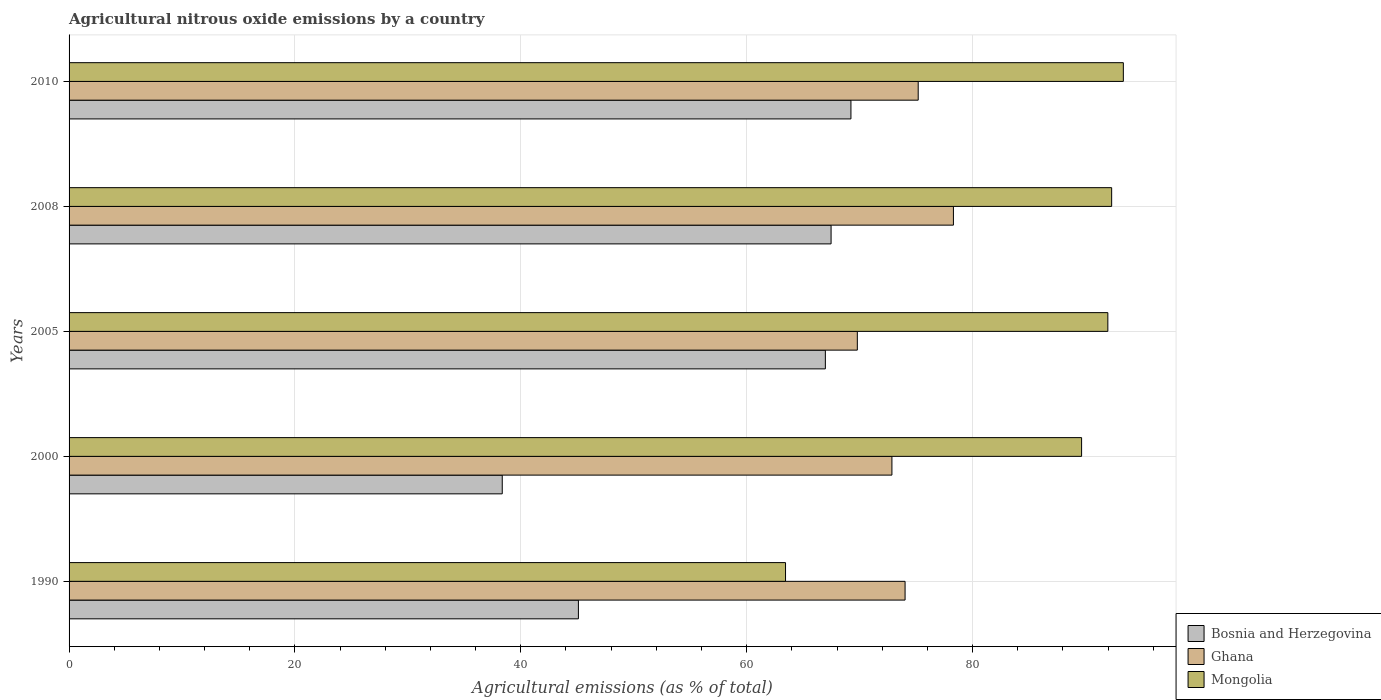How many different coloured bars are there?
Provide a succinct answer. 3. How many bars are there on the 3rd tick from the bottom?
Make the answer very short. 3. What is the amount of agricultural nitrous oxide emitted in Mongolia in 2005?
Provide a succinct answer. 91.98. Across all years, what is the maximum amount of agricultural nitrous oxide emitted in Ghana?
Offer a very short reply. 78.31. Across all years, what is the minimum amount of agricultural nitrous oxide emitted in Mongolia?
Your response must be concise. 63.44. In which year was the amount of agricultural nitrous oxide emitted in Ghana minimum?
Make the answer very short. 2005. What is the total amount of agricultural nitrous oxide emitted in Bosnia and Herzegovina in the graph?
Your answer should be very brief. 287.13. What is the difference between the amount of agricultural nitrous oxide emitted in Ghana in 2008 and that in 2010?
Your answer should be very brief. 3.12. What is the difference between the amount of agricultural nitrous oxide emitted in Mongolia in 2010 and the amount of agricultural nitrous oxide emitted in Bosnia and Herzegovina in 2000?
Give a very brief answer. 55. What is the average amount of agricultural nitrous oxide emitted in Bosnia and Herzegovina per year?
Offer a terse response. 57.43. In the year 1990, what is the difference between the amount of agricultural nitrous oxide emitted in Ghana and amount of agricultural nitrous oxide emitted in Bosnia and Herzegovina?
Offer a terse response. 28.93. In how many years, is the amount of agricultural nitrous oxide emitted in Mongolia greater than 92 %?
Offer a terse response. 2. What is the ratio of the amount of agricultural nitrous oxide emitted in Ghana in 2005 to that in 2008?
Provide a succinct answer. 0.89. Is the amount of agricultural nitrous oxide emitted in Bosnia and Herzegovina in 2000 less than that in 2008?
Provide a succinct answer. Yes. What is the difference between the highest and the second highest amount of agricultural nitrous oxide emitted in Ghana?
Give a very brief answer. 3.12. What is the difference between the highest and the lowest amount of agricultural nitrous oxide emitted in Mongolia?
Provide a succinct answer. 29.91. In how many years, is the amount of agricultural nitrous oxide emitted in Ghana greater than the average amount of agricultural nitrous oxide emitted in Ghana taken over all years?
Give a very brief answer. 2. Is the sum of the amount of agricultural nitrous oxide emitted in Bosnia and Herzegovina in 2005 and 2008 greater than the maximum amount of agricultural nitrous oxide emitted in Ghana across all years?
Your answer should be compact. Yes. What does the 3rd bar from the top in 2005 represents?
Provide a short and direct response. Bosnia and Herzegovina. Are all the bars in the graph horizontal?
Provide a short and direct response. Yes. Are the values on the major ticks of X-axis written in scientific E-notation?
Keep it short and to the point. No. Does the graph contain any zero values?
Make the answer very short. No. Does the graph contain grids?
Offer a terse response. Yes. How are the legend labels stacked?
Make the answer very short. Vertical. What is the title of the graph?
Keep it short and to the point. Agricultural nitrous oxide emissions by a country. Does "Timor-Leste" appear as one of the legend labels in the graph?
Offer a terse response. No. What is the label or title of the X-axis?
Your answer should be very brief. Agricultural emissions (as % of total). What is the Agricultural emissions (as % of total) of Bosnia and Herzegovina in 1990?
Offer a terse response. 45.1. What is the Agricultural emissions (as % of total) in Ghana in 1990?
Your answer should be very brief. 74.03. What is the Agricultural emissions (as % of total) of Mongolia in 1990?
Make the answer very short. 63.44. What is the Agricultural emissions (as % of total) of Bosnia and Herzegovina in 2000?
Give a very brief answer. 38.36. What is the Agricultural emissions (as % of total) in Ghana in 2000?
Your response must be concise. 72.86. What is the Agricultural emissions (as % of total) of Mongolia in 2000?
Your response must be concise. 89.66. What is the Agricultural emissions (as % of total) of Bosnia and Herzegovina in 2005?
Provide a succinct answer. 66.97. What is the Agricultural emissions (as % of total) of Ghana in 2005?
Your answer should be compact. 69.8. What is the Agricultural emissions (as % of total) of Mongolia in 2005?
Ensure brevity in your answer.  91.98. What is the Agricultural emissions (as % of total) of Bosnia and Herzegovina in 2008?
Make the answer very short. 67.47. What is the Agricultural emissions (as % of total) in Ghana in 2008?
Your answer should be very brief. 78.31. What is the Agricultural emissions (as % of total) of Mongolia in 2008?
Give a very brief answer. 92.32. What is the Agricultural emissions (as % of total) of Bosnia and Herzegovina in 2010?
Offer a terse response. 69.23. What is the Agricultural emissions (as % of total) in Ghana in 2010?
Your response must be concise. 75.19. What is the Agricultural emissions (as % of total) of Mongolia in 2010?
Keep it short and to the point. 93.35. Across all years, what is the maximum Agricultural emissions (as % of total) of Bosnia and Herzegovina?
Your response must be concise. 69.23. Across all years, what is the maximum Agricultural emissions (as % of total) in Ghana?
Provide a short and direct response. 78.31. Across all years, what is the maximum Agricultural emissions (as % of total) of Mongolia?
Your response must be concise. 93.35. Across all years, what is the minimum Agricultural emissions (as % of total) in Bosnia and Herzegovina?
Ensure brevity in your answer.  38.36. Across all years, what is the minimum Agricultural emissions (as % of total) in Ghana?
Keep it short and to the point. 69.8. Across all years, what is the minimum Agricultural emissions (as % of total) in Mongolia?
Your answer should be compact. 63.44. What is the total Agricultural emissions (as % of total) of Bosnia and Herzegovina in the graph?
Provide a short and direct response. 287.13. What is the total Agricultural emissions (as % of total) in Ghana in the graph?
Your answer should be compact. 370.18. What is the total Agricultural emissions (as % of total) in Mongolia in the graph?
Ensure brevity in your answer.  430.75. What is the difference between the Agricultural emissions (as % of total) of Bosnia and Herzegovina in 1990 and that in 2000?
Offer a terse response. 6.74. What is the difference between the Agricultural emissions (as % of total) in Ghana in 1990 and that in 2000?
Keep it short and to the point. 1.17. What is the difference between the Agricultural emissions (as % of total) of Mongolia in 1990 and that in 2000?
Keep it short and to the point. -26.22. What is the difference between the Agricultural emissions (as % of total) of Bosnia and Herzegovina in 1990 and that in 2005?
Ensure brevity in your answer.  -21.87. What is the difference between the Agricultural emissions (as % of total) in Ghana in 1990 and that in 2005?
Give a very brief answer. 4.23. What is the difference between the Agricultural emissions (as % of total) in Mongolia in 1990 and that in 2005?
Make the answer very short. -28.54. What is the difference between the Agricultural emissions (as % of total) of Bosnia and Herzegovina in 1990 and that in 2008?
Offer a very short reply. -22.37. What is the difference between the Agricultural emissions (as % of total) in Ghana in 1990 and that in 2008?
Your response must be concise. -4.28. What is the difference between the Agricultural emissions (as % of total) of Mongolia in 1990 and that in 2008?
Keep it short and to the point. -28.88. What is the difference between the Agricultural emissions (as % of total) in Bosnia and Herzegovina in 1990 and that in 2010?
Your answer should be compact. -24.13. What is the difference between the Agricultural emissions (as % of total) of Ghana in 1990 and that in 2010?
Keep it short and to the point. -1.16. What is the difference between the Agricultural emissions (as % of total) of Mongolia in 1990 and that in 2010?
Your response must be concise. -29.91. What is the difference between the Agricultural emissions (as % of total) in Bosnia and Herzegovina in 2000 and that in 2005?
Keep it short and to the point. -28.61. What is the difference between the Agricultural emissions (as % of total) in Ghana in 2000 and that in 2005?
Ensure brevity in your answer.  3.06. What is the difference between the Agricultural emissions (as % of total) of Mongolia in 2000 and that in 2005?
Keep it short and to the point. -2.32. What is the difference between the Agricultural emissions (as % of total) of Bosnia and Herzegovina in 2000 and that in 2008?
Your response must be concise. -29.12. What is the difference between the Agricultural emissions (as % of total) of Ghana in 2000 and that in 2008?
Ensure brevity in your answer.  -5.45. What is the difference between the Agricultural emissions (as % of total) in Mongolia in 2000 and that in 2008?
Offer a terse response. -2.66. What is the difference between the Agricultural emissions (as % of total) of Bosnia and Herzegovina in 2000 and that in 2010?
Offer a terse response. -30.88. What is the difference between the Agricultural emissions (as % of total) in Ghana in 2000 and that in 2010?
Offer a very short reply. -2.33. What is the difference between the Agricultural emissions (as % of total) in Mongolia in 2000 and that in 2010?
Your response must be concise. -3.7. What is the difference between the Agricultural emissions (as % of total) of Bosnia and Herzegovina in 2005 and that in 2008?
Provide a succinct answer. -0.51. What is the difference between the Agricultural emissions (as % of total) in Ghana in 2005 and that in 2008?
Give a very brief answer. -8.51. What is the difference between the Agricultural emissions (as % of total) of Mongolia in 2005 and that in 2008?
Provide a short and direct response. -0.34. What is the difference between the Agricultural emissions (as % of total) of Bosnia and Herzegovina in 2005 and that in 2010?
Keep it short and to the point. -2.27. What is the difference between the Agricultural emissions (as % of total) in Ghana in 2005 and that in 2010?
Ensure brevity in your answer.  -5.39. What is the difference between the Agricultural emissions (as % of total) in Mongolia in 2005 and that in 2010?
Offer a terse response. -1.37. What is the difference between the Agricultural emissions (as % of total) of Bosnia and Herzegovina in 2008 and that in 2010?
Ensure brevity in your answer.  -1.76. What is the difference between the Agricultural emissions (as % of total) in Ghana in 2008 and that in 2010?
Provide a succinct answer. 3.12. What is the difference between the Agricultural emissions (as % of total) in Mongolia in 2008 and that in 2010?
Offer a terse response. -1.03. What is the difference between the Agricultural emissions (as % of total) of Bosnia and Herzegovina in 1990 and the Agricultural emissions (as % of total) of Ghana in 2000?
Your answer should be compact. -27.76. What is the difference between the Agricultural emissions (as % of total) of Bosnia and Herzegovina in 1990 and the Agricultural emissions (as % of total) of Mongolia in 2000?
Provide a short and direct response. -44.56. What is the difference between the Agricultural emissions (as % of total) in Ghana in 1990 and the Agricultural emissions (as % of total) in Mongolia in 2000?
Give a very brief answer. -15.63. What is the difference between the Agricultural emissions (as % of total) of Bosnia and Herzegovina in 1990 and the Agricultural emissions (as % of total) of Ghana in 2005?
Provide a succinct answer. -24.7. What is the difference between the Agricultural emissions (as % of total) of Bosnia and Herzegovina in 1990 and the Agricultural emissions (as % of total) of Mongolia in 2005?
Your answer should be very brief. -46.88. What is the difference between the Agricultural emissions (as % of total) in Ghana in 1990 and the Agricultural emissions (as % of total) in Mongolia in 2005?
Provide a succinct answer. -17.95. What is the difference between the Agricultural emissions (as % of total) in Bosnia and Herzegovina in 1990 and the Agricultural emissions (as % of total) in Ghana in 2008?
Your answer should be compact. -33.21. What is the difference between the Agricultural emissions (as % of total) in Bosnia and Herzegovina in 1990 and the Agricultural emissions (as % of total) in Mongolia in 2008?
Keep it short and to the point. -47.22. What is the difference between the Agricultural emissions (as % of total) in Ghana in 1990 and the Agricultural emissions (as % of total) in Mongolia in 2008?
Keep it short and to the point. -18.29. What is the difference between the Agricultural emissions (as % of total) of Bosnia and Herzegovina in 1990 and the Agricultural emissions (as % of total) of Ghana in 2010?
Your answer should be very brief. -30.09. What is the difference between the Agricultural emissions (as % of total) in Bosnia and Herzegovina in 1990 and the Agricultural emissions (as % of total) in Mongolia in 2010?
Your response must be concise. -48.25. What is the difference between the Agricultural emissions (as % of total) of Ghana in 1990 and the Agricultural emissions (as % of total) of Mongolia in 2010?
Your answer should be very brief. -19.33. What is the difference between the Agricultural emissions (as % of total) of Bosnia and Herzegovina in 2000 and the Agricultural emissions (as % of total) of Ghana in 2005?
Your response must be concise. -31.44. What is the difference between the Agricultural emissions (as % of total) in Bosnia and Herzegovina in 2000 and the Agricultural emissions (as % of total) in Mongolia in 2005?
Keep it short and to the point. -53.62. What is the difference between the Agricultural emissions (as % of total) of Ghana in 2000 and the Agricultural emissions (as % of total) of Mongolia in 2005?
Your answer should be compact. -19.12. What is the difference between the Agricultural emissions (as % of total) in Bosnia and Herzegovina in 2000 and the Agricultural emissions (as % of total) in Ghana in 2008?
Your answer should be compact. -39.95. What is the difference between the Agricultural emissions (as % of total) in Bosnia and Herzegovina in 2000 and the Agricultural emissions (as % of total) in Mongolia in 2008?
Your answer should be very brief. -53.96. What is the difference between the Agricultural emissions (as % of total) of Ghana in 2000 and the Agricultural emissions (as % of total) of Mongolia in 2008?
Provide a succinct answer. -19.46. What is the difference between the Agricultural emissions (as % of total) of Bosnia and Herzegovina in 2000 and the Agricultural emissions (as % of total) of Ghana in 2010?
Give a very brief answer. -36.83. What is the difference between the Agricultural emissions (as % of total) of Bosnia and Herzegovina in 2000 and the Agricultural emissions (as % of total) of Mongolia in 2010?
Your answer should be very brief. -55. What is the difference between the Agricultural emissions (as % of total) of Ghana in 2000 and the Agricultural emissions (as % of total) of Mongolia in 2010?
Offer a terse response. -20.49. What is the difference between the Agricultural emissions (as % of total) of Bosnia and Herzegovina in 2005 and the Agricultural emissions (as % of total) of Ghana in 2008?
Offer a very short reply. -11.34. What is the difference between the Agricultural emissions (as % of total) in Bosnia and Herzegovina in 2005 and the Agricultural emissions (as % of total) in Mongolia in 2008?
Offer a very short reply. -25.35. What is the difference between the Agricultural emissions (as % of total) in Ghana in 2005 and the Agricultural emissions (as % of total) in Mongolia in 2008?
Give a very brief answer. -22.52. What is the difference between the Agricultural emissions (as % of total) in Bosnia and Herzegovina in 2005 and the Agricultural emissions (as % of total) in Ghana in 2010?
Offer a terse response. -8.22. What is the difference between the Agricultural emissions (as % of total) of Bosnia and Herzegovina in 2005 and the Agricultural emissions (as % of total) of Mongolia in 2010?
Provide a succinct answer. -26.39. What is the difference between the Agricultural emissions (as % of total) of Ghana in 2005 and the Agricultural emissions (as % of total) of Mongolia in 2010?
Make the answer very short. -23.55. What is the difference between the Agricultural emissions (as % of total) in Bosnia and Herzegovina in 2008 and the Agricultural emissions (as % of total) in Ghana in 2010?
Offer a terse response. -7.71. What is the difference between the Agricultural emissions (as % of total) in Bosnia and Herzegovina in 2008 and the Agricultural emissions (as % of total) in Mongolia in 2010?
Give a very brief answer. -25.88. What is the difference between the Agricultural emissions (as % of total) of Ghana in 2008 and the Agricultural emissions (as % of total) of Mongolia in 2010?
Make the answer very short. -15.05. What is the average Agricultural emissions (as % of total) in Bosnia and Herzegovina per year?
Your answer should be compact. 57.43. What is the average Agricultural emissions (as % of total) of Ghana per year?
Your answer should be very brief. 74.04. What is the average Agricultural emissions (as % of total) of Mongolia per year?
Give a very brief answer. 86.15. In the year 1990, what is the difference between the Agricultural emissions (as % of total) of Bosnia and Herzegovina and Agricultural emissions (as % of total) of Ghana?
Offer a very short reply. -28.93. In the year 1990, what is the difference between the Agricultural emissions (as % of total) of Bosnia and Herzegovina and Agricultural emissions (as % of total) of Mongolia?
Ensure brevity in your answer.  -18.34. In the year 1990, what is the difference between the Agricultural emissions (as % of total) in Ghana and Agricultural emissions (as % of total) in Mongolia?
Make the answer very short. 10.59. In the year 2000, what is the difference between the Agricultural emissions (as % of total) in Bosnia and Herzegovina and Agricultural emissions (as % of total) in Ghana?
Your answer should be very brief. -34.5. In the year 2000, what is the difference between the Agricultural emissions (as % of total) in Bosnia and Herzegovina and Agricultural emissions (as % of total) in Mongolia?
Your answer should be compact. -51.3. In the year 2000, what is the difference between the Agricultural emissions (as % of total) of Ghana and Agricultural emissions (as % of total) of Mongolia?
Your answer should be compact. -16.8. In the year 2005, what is the difference between the Agricultural emissions (as % of total) of Bosnia and Herzegovina and Agricultural emissions (as % of total) of Ghana?
Your answer should be very brief. -2.83. In the year 2005, what is the difference between the Agricultural emissions (as % of total) of Bosnia and Herzegovina and Agricultural emissions (as % of total) of Mongolia?
Your response must be concise. -25.01. In the year 2005, what is the difference between the Agricultural emissions (as % of total) in Ghana and Agricultural emissions (as % of total) in Mongolia?
Keep it short and to the point. -22.18. In the year 2008, what is the difference between the Agricultural emissions (as % of total) of Bosnia and Herzegovina and Agricultural emissions (as % of total) of Ghana?
Provide a succinct answer. -10.83. In the year 2008, what is the difference between the Agricultural emissions (as % of total) in Bosnia and Herzegovina and Agricultural emissions (as % of total) in Mongolia?
Your answer should be very brief. -24.84. In the year 2008, what is the difference between the Agricultural emissions (as % of total) in Ghana and Agricultural emissions (as % of total) in Mongolia?
Ensure brevity in your answer.  -14.01. In the year 2010, what is the difference between the Agricultural emissions (as % of total) in Bosnia and Herzegovina and Agricultural emissions (as % of total) in Ghana?
Your answer should be very brief. -5.96. In the year 2010, what is the difference between the Agricultural emissions (as % of total) of Bosnia and Herzegovina and Agricultural emissions (as % of total) of Mongolia?
Make the answer very short. -24.12. In the year 2010, what is the difference between the Agricultural emissions (as % of total) of Ghana and Agricultural emissions (as % of total) of Mongolia?
Make the answer very short. -18.16. What is the ratio of the Agricultural emissions (as % of total) in Bosnia and Herzegovina in 1990 to that in 2000?
Offer a terse response. 1.18. What is the ratio of the Agricultural emissions (as % of total) of Ghana in 1990 to that in 2000?
Make the answer very short. 1.02. What is the ratio of the Agricultural emissions (as % of total) in Mongolia in 1990 to that in 2000?
Make the answer very short. 0.71. What is the ratio of the Agricultural emissions (as % of total) in Bosnia and Herzegovina in 1990 to that in 2005?
Your answer should be compact. 0.67. What is the ratio of the Agricultural emissions (as % of total) of Ghana in 1990 to that in 2005?
Your answer should be compact. 1.06. What is the ratio of the Agricultural emissions (as % of total) of Mongolia in 1990 to that in 2005?
Make the answer very short. 0.69. What is the ratio of the Agricultural emissions (as % of total) of Bosnia and Herzegovina in 1990 to that in 2008?
Provide a short and direct response. 0.67. What is the ratio of the Agricultural emissions (as % of total) in Ghana in 1990 to that in 2008?
Your answer should be compact. 0.95. What is the ratio of the Agricultural emissions (as % of total) of Mongolia in 1990 to that in 2008?
Offer a terse response. 0.69. What is the ratio of the Agricultural emissions (as % of total) of Bosnia and Herzegovina in 1990 to that in 2010?
Your answer should be compact. 0.65. What is the ratio of the Agricultural emissions (as % of total) of Ghana in 1990 to that in 2010?
Ensure brevity in your answer.  0.98. What is the ratio of the Agricultural emissions (as % of total) of Mongolia in 1990 to that in 2010?
Offer a very short reply. 0.68. What is the ratio of the Agricultural emissions (as % of total) of Bosnia and Herzegovina in 2000 to that in 2005?
Your answer should be very brief. 0.57. What is the ratio of the Agricultural emissions (as % of total) of Ghana in 2000 to that in 2005?
Your answer should be compact. 1.04. What is the ratio of the Agricultural emissions (as % of total) in Mongolia in 2000 to that in 2005?
Offer a very short reply. 0.97. What is the ratio of the Agricultural emissions (as % of total) of Bosnia and Herzegovina in 2000 to that in 2008?
Ensure brevity in your answer.  0.57. What is the ratio of the Agricultural emissions (as % of total) of Ghana in 2000 to that in 2008?
Give a very brief answer. 0.93. What is the ratio of the Agricultural emissions (as % of total) of Mongolia in 2000 to that in 2008?
Keep it short and to the point. 0.97. What is the ratio of the Agricultural emissions (as % of total) of Bosnia and Herzegovina in 2000 to that in 2010?
Provide a short and direct response. 0.55. What is the ratio of the Agricultural emissions (as % of total) in Ghana in 2000 to that in 2010?
Your answer should be compact. 0.97. What is the ratio of the Agricultural emissions (as % of total) in Mongolia in 2000 to that in 2010?
Offer a terse response. 0.96. What is the ratio of the Agricultural emissions (as % of total) in Ghana in 2005 to that in 2008?
Your response must be concise. 0.89. What is the ratio of the Agricultural emissions (as % of total) of Mongolia in 2005 to that in 2008?
Your answer should be very brief. 1. What is the ratio of the Agricultural emissions (as % of total) in Bosnia and Herzegovina in 2005 to that in 2010?
Offer a very short reply. 0.97. What is the ratio of the Agricultural emissions (as % of total) in Ghana in 2005 to that in 2010?
Provide a short and direct response. 0.93. What is the ratio of the Agricultural emissions (as % of total) of Mongolia in 2005 to that in 2010?
Your answer should be compact. 0.99. What is the ratio of the Agricultural emissions (as % of total) in Bosnia and Herzegovina in 2008 to that in 2010?
Make the answer very short. 0.97. What is the ratio of the Agricultural emissions (as % of total) of Ghana in 2008 to that in 2010?
Provide a short and direct response. 1.04. What is the ratio of the Agricultural emissions (as % of total) in Mongolia in 2008 to that in 2010?
Make the answer very short. 0.99. What is the difference between the highest and the second highest Agricultural emissions (as % of total) of Bosnia and Herzegovina?
Your response must be concise. 1.76. What is the difference between the highest and the second highest Agricultural emissions (as % of total) of Ghana?
Make the answer very short. 3.12. What is the difference between the highest and the second highest Agricultural emissions (as % of total) of Mongolia?
Your answer should be very brief. 1.03. What is the difference between the highest and the lowest Agricultural emissions (as % of total) of Bosnia and Herzegovina?
Your response must be concise. 30.88. What is the difference between the highest and the lowest Agricultural emissions (as % of total) in Ghana?
Offer a terse response. 8.51. What is the difference between the highest and the lowest Agricultural emissions (as % of total) of Mongolia?
Provide a succinct answer. 29.91. 